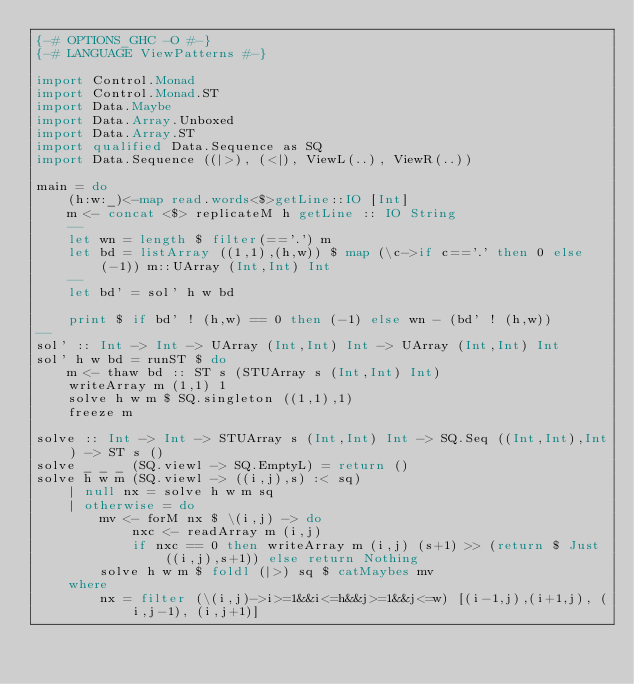Convert code to text. <code><loc_0><loc_0><loc_500><loc_500><_Haskell_>{-# OPTIONS_GHC -O #-}
{-# LANGUAGE ViewPatterns #-}

import Control.Monad
import Control.Monad.ST
import Data.Maybe
import Data.Array.Unboxed
import Data.Array.ST
import qualified Data.Sequence as SQ
import Data.Sequence ((|>), (<|), ViewL(..), ViewR(..))

main = do
    (h:w:_)<-map read.words<$>getLine::IO [Int]
    m <- concat <$> replicateM h getLine :: IO String
    --
    let wn = length $ filter(=='.') m
    let bd = listArray ((1,1),(h,w)) $ map (\c->if c=='.' then 0 else (-1)) m::UArray (Int,Int) Int
    --
    let bd' = sol' h w bd

    print $ if bd' ! (h,w) == 0 then (-1) else wn - (bd' ! (h,w))
--
sol' :: Int -> Int -> UArray (Int,Int) Int -> UArray (Int,Int) Int
sol' h w bd = runST $ do
    m <- thaw bd :: ST s (STUArray s (Int,Int) Int)
    writeArray m (1,1) 1
    solve h w m $ SQ.singleton ((1,1),1)
    freeze m

solve :: Int -> Int -> STUArray s (Int,Int) Int -> SQ.Seq ((Int,Int),Int) -> ST s ()
solve _ _ _ (SQ.viewl -> SQ.EmptyL) = return ()
solve h w m (SQ.viewl -> ((i,j),s) :< sq)
    | null nx = solve h w m sq
    | otherwise = do
        mv <- forM nx $ \(i,j) -> do
            nxc <- readArray m (i,j)
            if nxc == 0 then writeArray m (i,j) (s+1) >> (return $ Just ((i,j),s+1)) else return Nothing
        solve h w m $ foldl (|>) sq $ catMaybes mv
    where
        nx = filter (\(i,j)->i>=1&&i<=h&&j>=1&&j<=w) [(i-1,j),(i+1,j), (i,j-1), (i,j+1)]</code> 